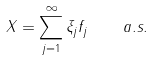<formula> <loc_0><loc_0><loc_500><loc_500>X = \sum ^ { \infty } _ { j = 1 } \xi _ { j } f _ { j } \quad a . s .</formula> 